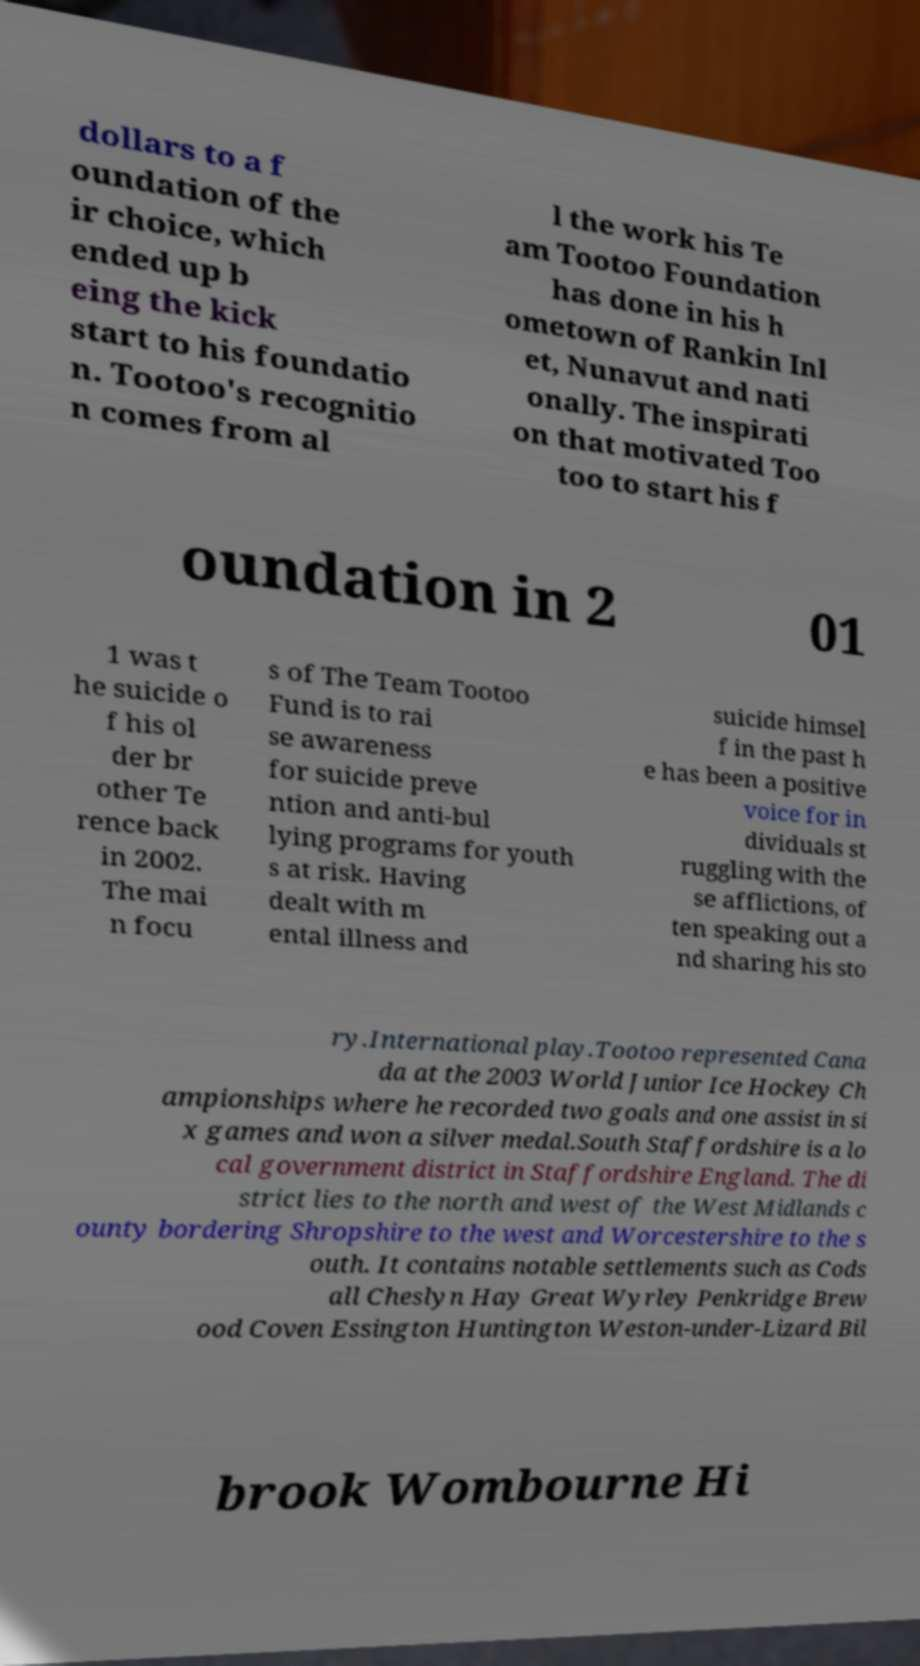There's text embedded in this image that I need extracted. Can you transcribe it verbatim? dollars to a f oundation of the ir choice, which ended up b eing the kick start to his foundatio n. Tootoo's recognitio n comes from al l the work his Te am Tootoo Foundation has done in his h ometown of Rankin Inl et, Nunavut and nati onally. The inspirati on that motivated Too too to start his f oundation in 2 01 1 was t he suicide o f his ol der br other Te rence back in 2002. The mai n focu s of The Team Tootoo Fund is to rai se awareness for suicide preve ntion and anti-bul lying programs for youth s at risk. Having dealt with m ental illness and suicide himsel f in the past h e has been a positive voice for in dividuals st ruggling with the se afflictions, of ten speaking out a nd sharing his sto ry.International play.Tootoo represented Cana da at the 2003 World Junior Ice Hockey Ch ampionships where he recorded two goals and one assist in si x games and won a silver medal.South Staffordshire is a lo cal government district in Staffordshire England. The di strict lies to the north and west of the West Midlands c ounty bordering Shropshire to the west and Worcestershire to the s outh. It contains notable settlements such as Cods all Cheslyn Hay Great Wyrley Penkridge Brew ood Coven Essington Huntington Weston-under-Lizard Bil brook Wombourne Hi 